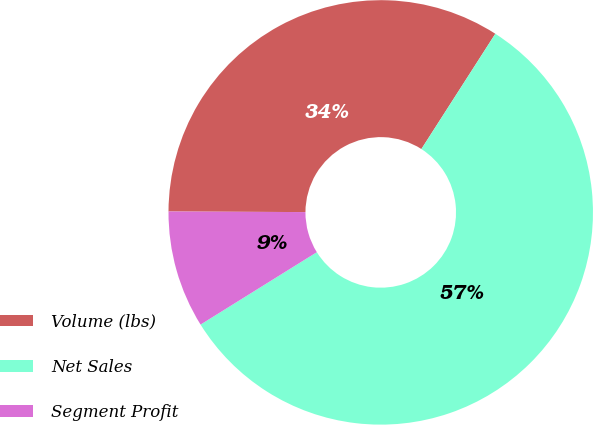<chart> <loc_0><loc_0><loc_500><loc_500><pie_chart><fcel>Volume (lbs)<fcel>Net Sales<fcel>Segment Profit<nl><fcel>34.01%<fcel>57.06%<fcel>8.93%<nl></chart> 